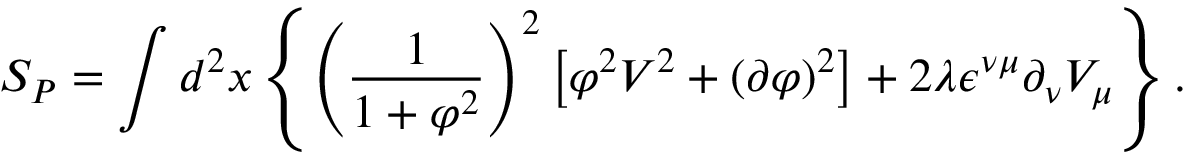<formula> <loc_0><loc_0><loc_500><loc_500>S _ { P } = \int d ^ { 2 } x \left \{ \left ( \frac { 1 } { 1 + \varphi ^ { 2 } } \right ) ^ { 2 } \left [ \varphi ^ { 2 } V ^ { 2 } + ( \partial \varphi ) ^ { 2 } \right ] + 2 \lambda \epsilon ^ { \nu \mu } \partial _ { \nu } V _ { \mu } \right \} .</formula> 